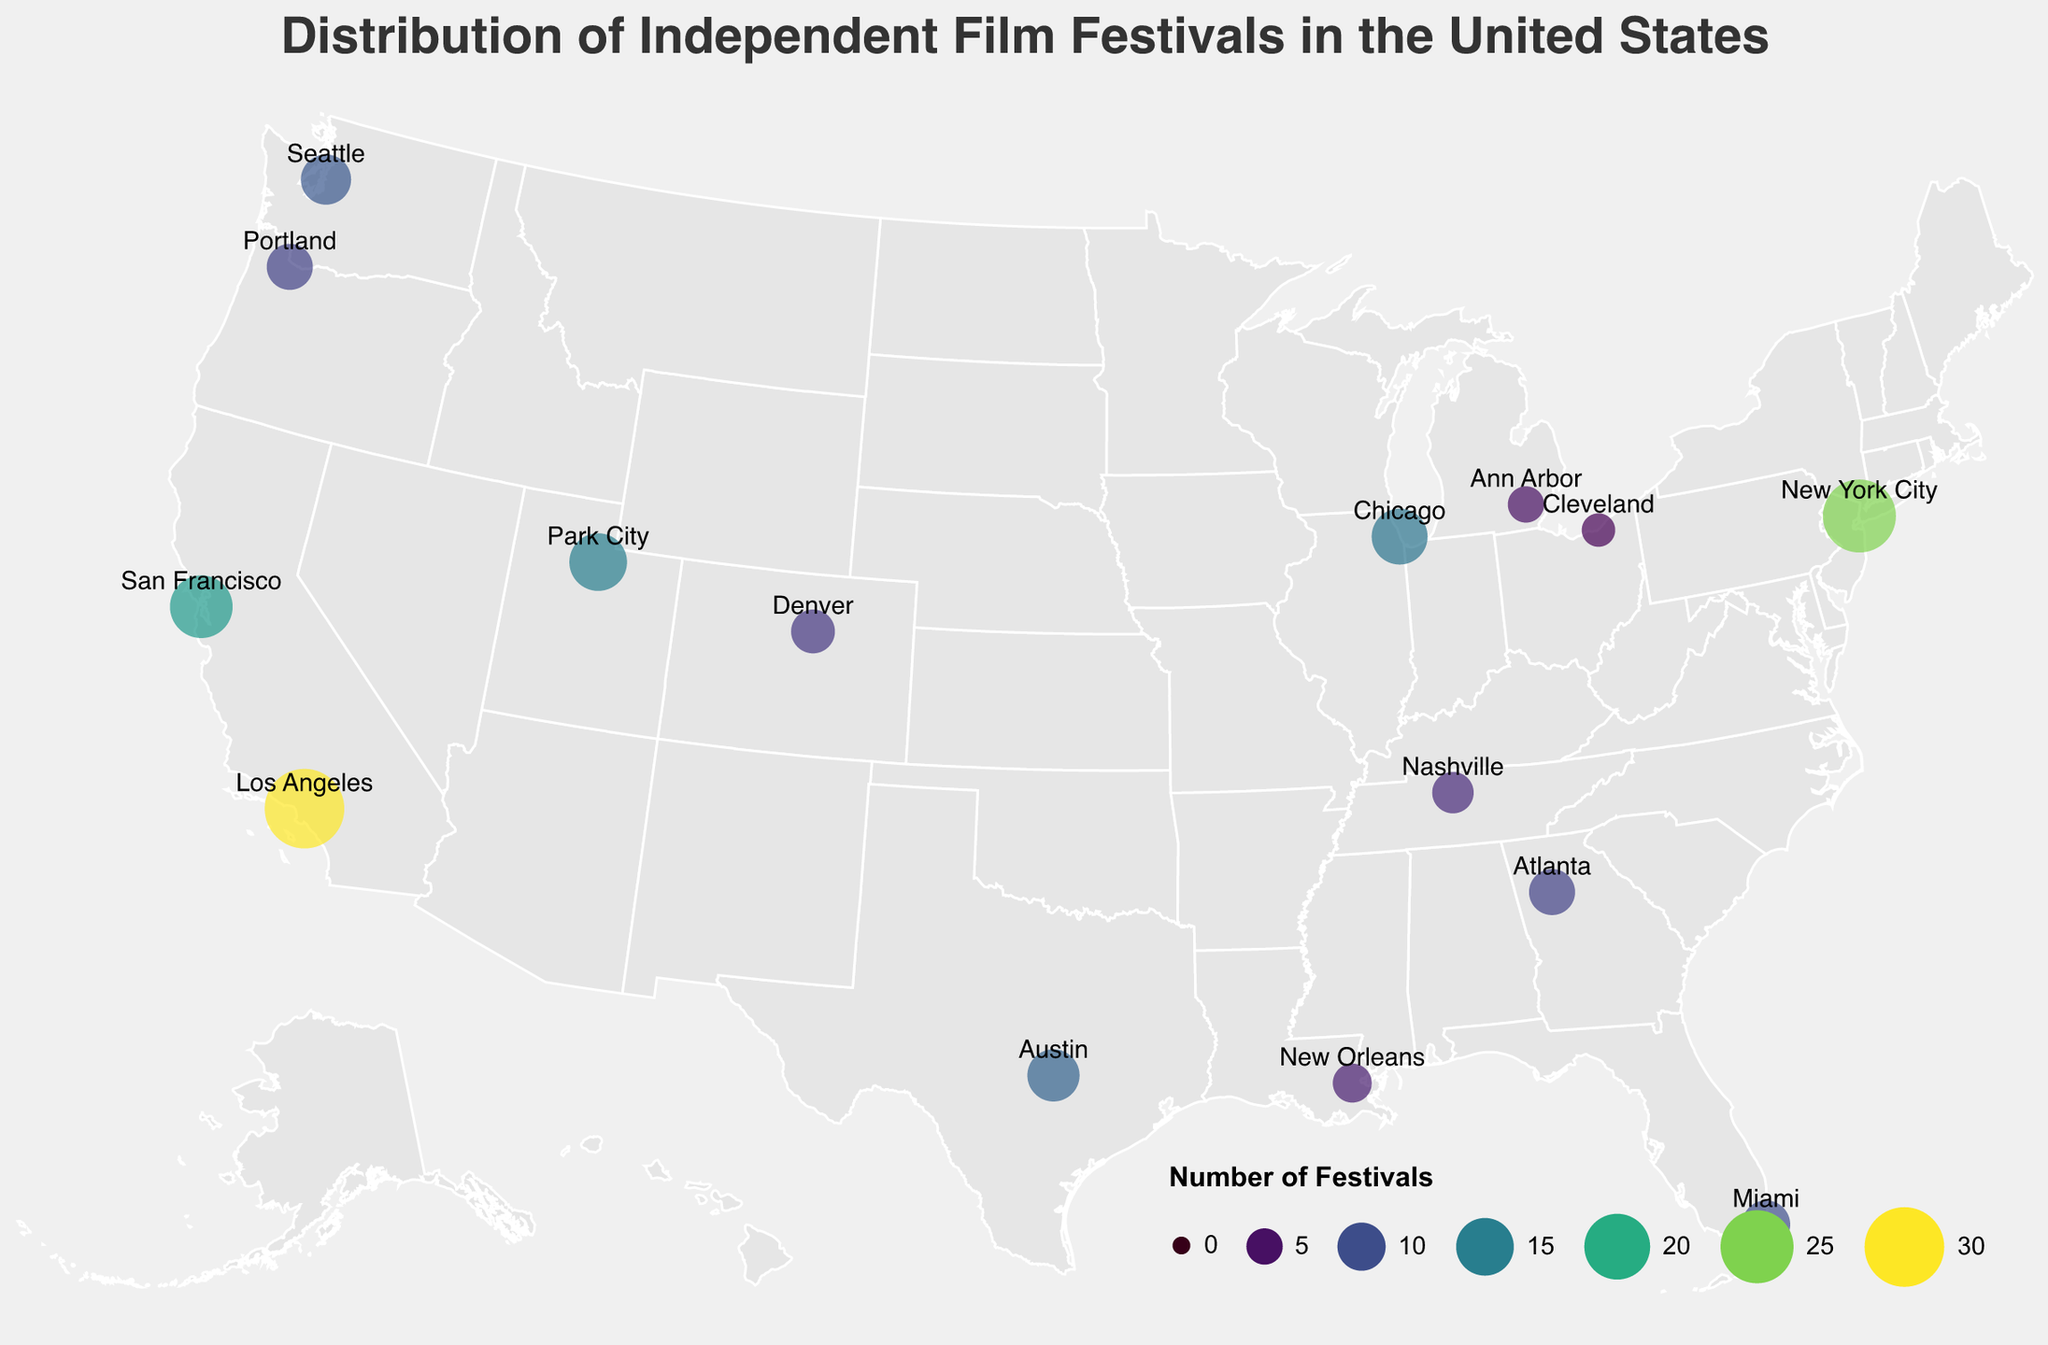What is the title of the figure? The title is typically located at the top of the figure and is easily readable. Here, the title text is shown as "Distribution of Independent Film Festivals in the United States" in a larger font size.
Answer: Distribution of Independent Film Festivals in the United States Which city has the highest number of independent film festivals? To find this, look for the city with the largest circle on the map. The color intensity and size indicate the number of festivals. Los Angeles has the largest circle.
Answer: Los Angeles How many more festivals does New York City have compared to Miami? Identify the festival counts for both New York City (25) and Miami (10). Subtract the smaller number from the larger number: 25 - 10.
Answer: 15 Which cities in California have a high concentration of independent film festivals? Look at the cities within the state of California and analyze their festival counts. Los Angeles has 30, and San Francisco has 18, both of which are relatively high.
Answer: Los Angeles and San Francisco What is the average number of festivals in the cities listed? Sum the festival counts: 15 + 12 + 25 + 30 + 18 + 14 + 10 + 11 + 9 + 8 + 7 + 6 + 9 + 5 + 4 = 183. Then, divide by the number of cities (15): 183 / 15.
Answer: 12.2 What is the color scheme used to represent the number of festivals? The color legend indicates the scale used, which is the "viridis" color scheme ranging from lesser to greater values in shades of green.
Answer: Viridis Which city is depicted as the southernmost point for independent film festivals? Observe the latitude values, with the southernmost latitude being the smallest positive value. Miami, Florida, at 25.7617 is the southernmost.
Answer: Miami Between Austin, Texas, and Chicago, Illinois, which has a higher concentration of festivals? Compare the festival counts for Austin (12) and Chicago (14). Chicago has the higher count.
Answer: Chicago Name two cities with a festival count between 9 and 14. Identify cities within the specified range. Seattle (11) and Chicago (14) meet this criteria.
Answer: Seattle and Chicago How many cities have fewer than 10 festivals? Count the cities with festival counts less than 10: Atlanta (9), Denver (8), Nashville (7), New Orleans (6), Portland (9), Ann Arbor (5), and Cleveland (4). There are 7 such cities.
Answer: 7 Is there a noticeable cluster of festivals in a specific region of the US? Identify areas with multiple circles close together with similar festival counts. California (Los Angeles and San Francisco) forms a noticeable cluster.
Answer: California 